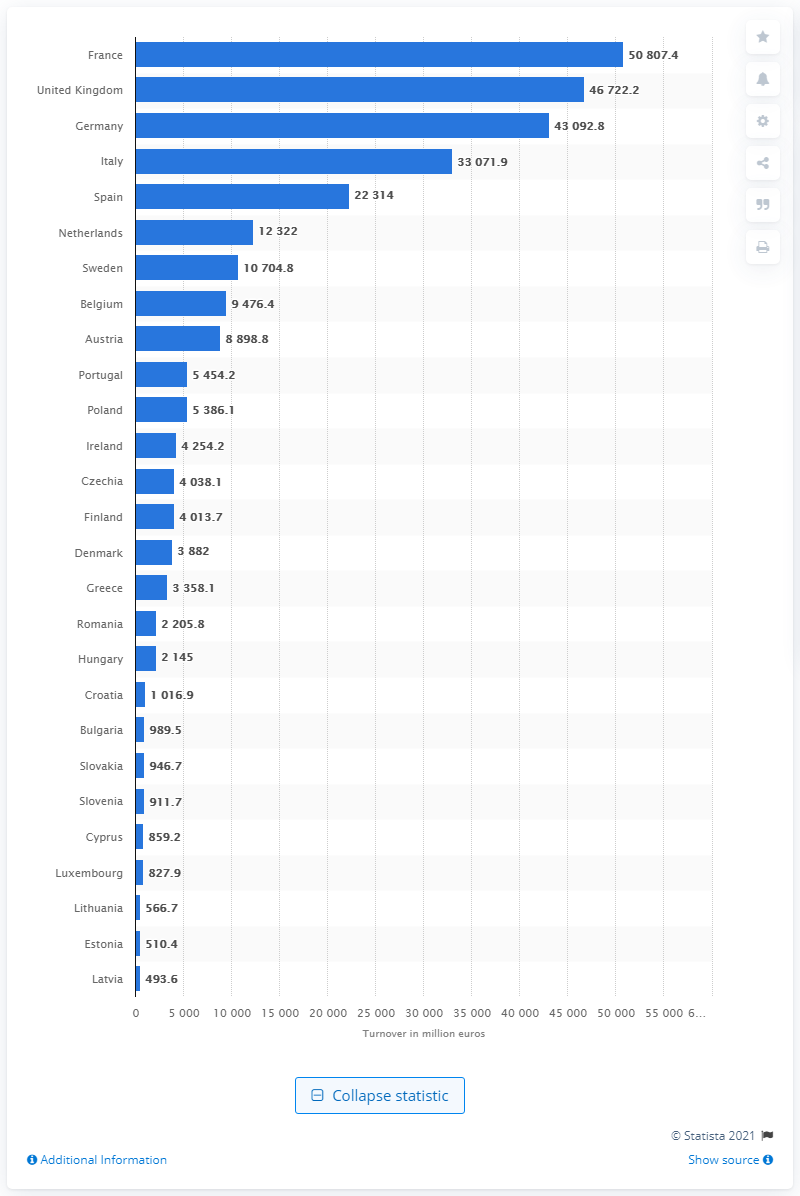Specify some key components in this picture. In 2017, the turnover of the restaurants and mobile food service activities industry in France was 50,807.4 million euros. 